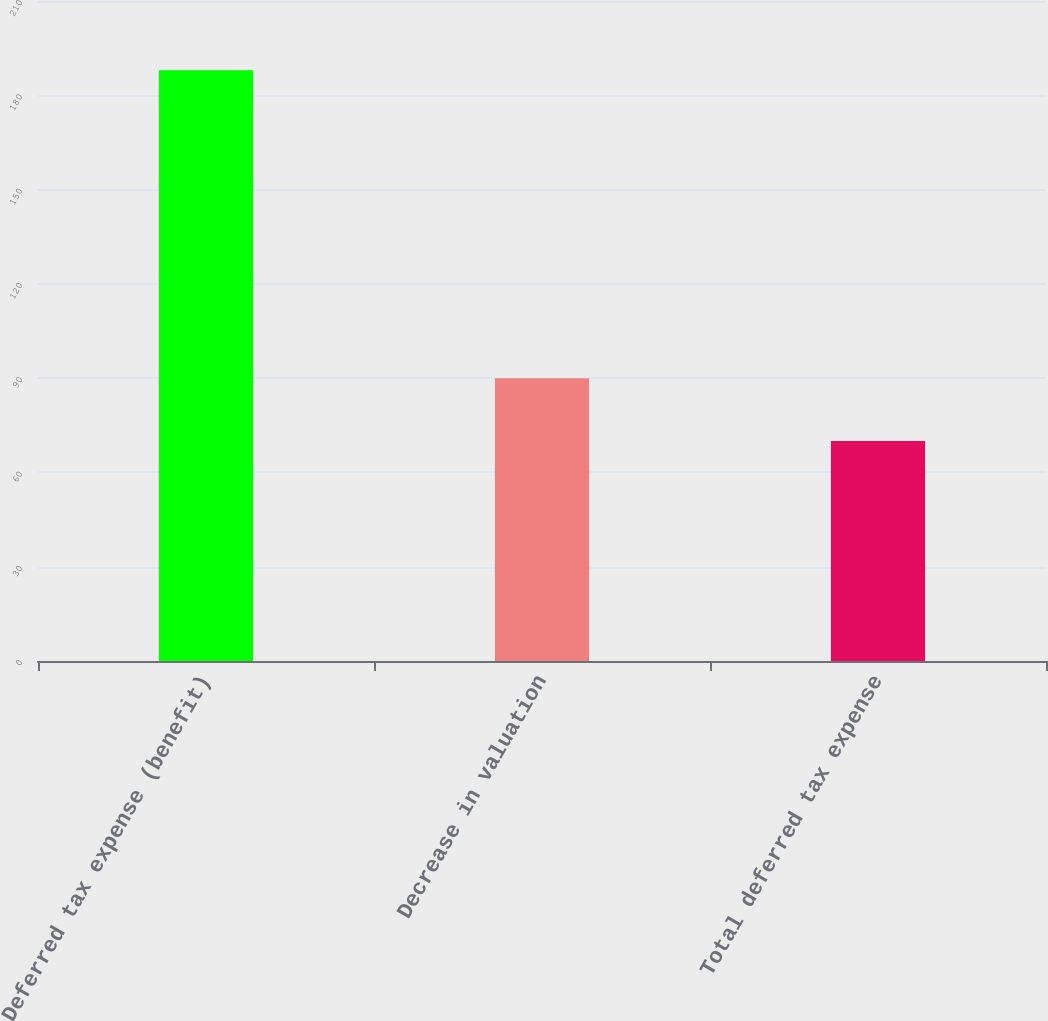Convert chart to OTSL. <chart><loc_0><loc_0><loc_500><loc_500><bar_chart><fcel>Deferred tax expense (benefit)<fcel>Decrease in valuation<fcel>Total deferred tax expense<nl><fcel>188<fcel>90<fcel>70<nl></chart> 